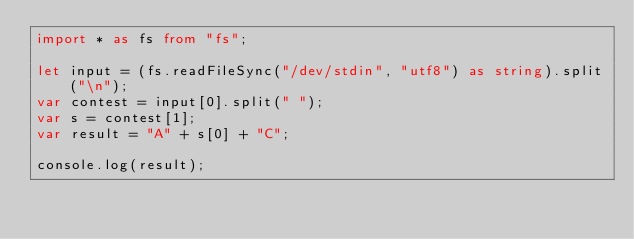<code> <loc_0><loc_0><loc_500><loc_500><_TypeScript_>import * as fs from "fs";
 
let input = (fs.readFileSync("/dev/stdin", "utf8") as string).split("\n");
var contest = input[0].split(" ");
var s = contest[1];
var result = "A" + s[0] + "C";

console.log(result);


</code> 